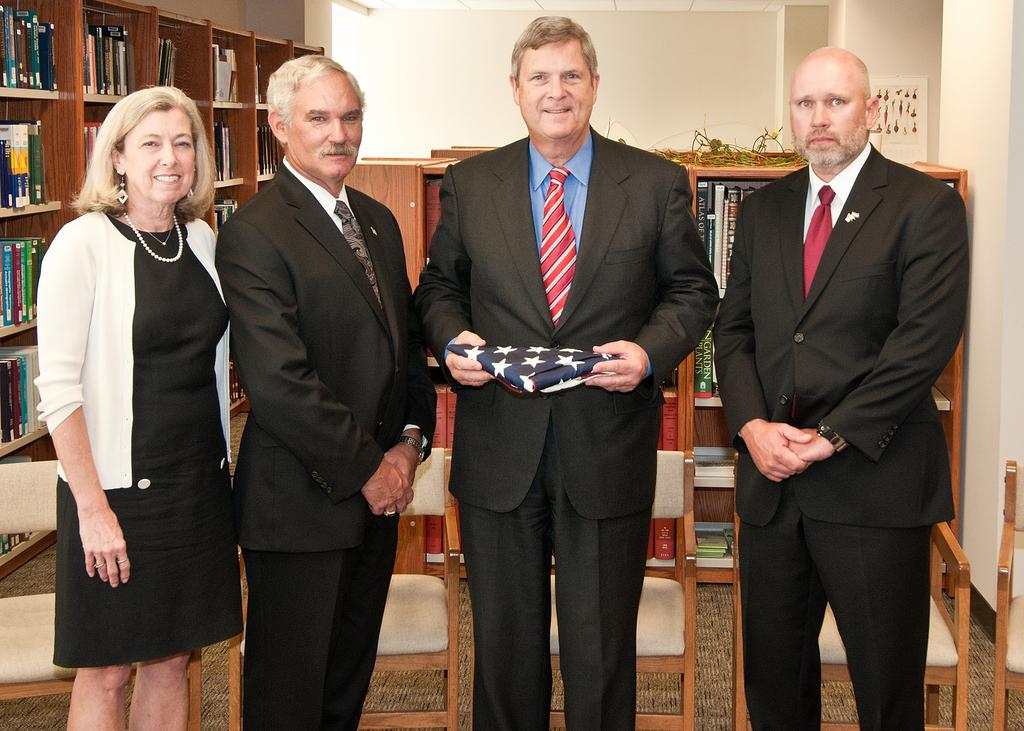How many people are present in the image? There are four people standing in the image. What is one person holding in their hand? One person is holding something in their hand, but the specific object is not mentioned in the facts. What can be seen in the background of the image? There is a cupboard with books and a wall in the background. What type of furniture is present in the image? There are chairs in the image. What type of engine can be seen in the image? There is no engine present in the image. Is there a toothbrush visible in the image? There is no toothbrush mentioned in the facts or visible in the image. 